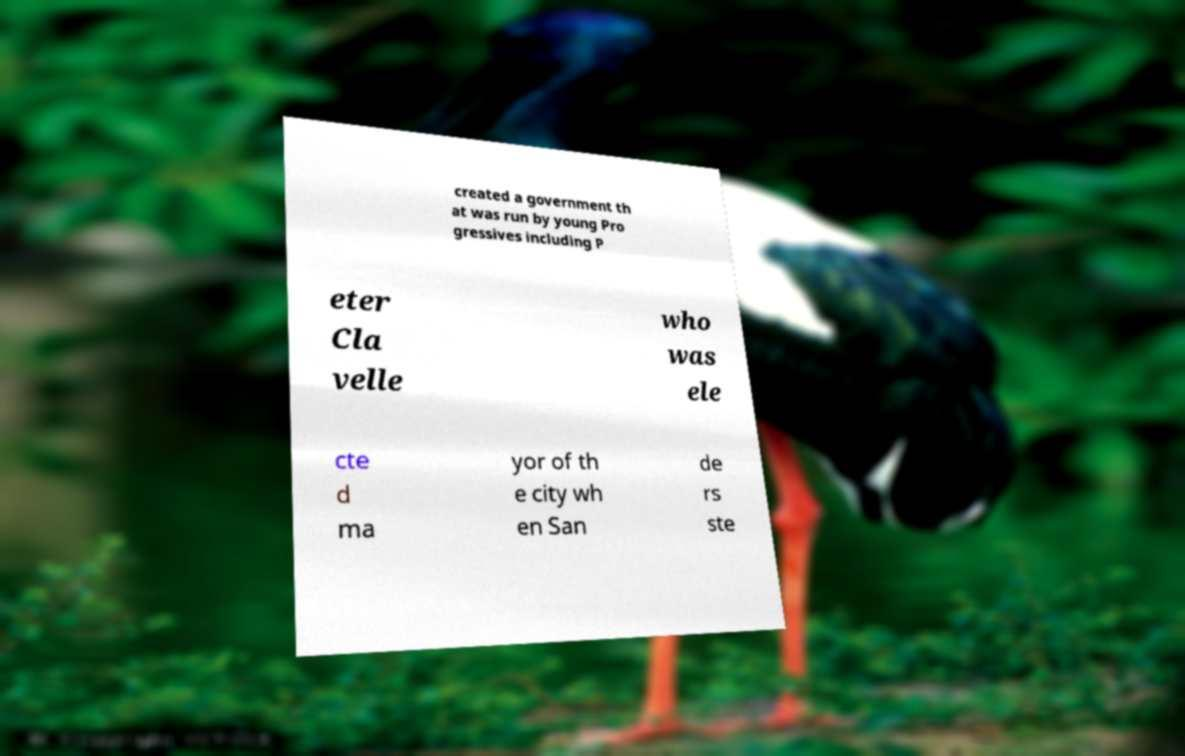What messages or text are displayed in this image? I need them in a readable, typed format. created a government th at was run by young Pro gressives including P eter Cla velle who was ele cte d ma yor of th e city wh en San de rs ste 